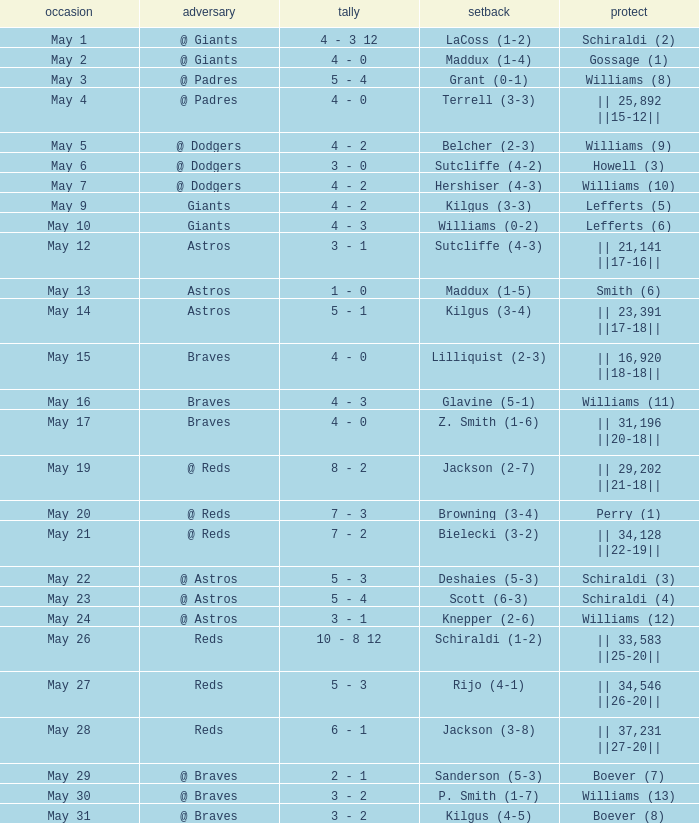Name the loss with save of || 23,391 ||17-18||? Kilgus (3-4). Could you help me parse every detail presented in this table? {'header': ['occasion', 'adversary', 'tally', 'setback', 'protect'], 'rows': [['May 1', '@ Giants', '4 - 3 12', 'LaCoss (1-2)', 'Schiraldi (2)'], ['May 2', '@ Giants', '4 - 0', 'Maddux (1-4)', 'Gossage (1)'], ['May 3', '@ Padres', '5 - 4', 'Grant (0-1)', 'Williams (8)'], ['May 4', '@ Padres', '4 - 0', 'Terrell (3-3)', '|| 25,892 ||15-12||'], ['May 5', '@ Dodgers', '4 - 2', 'Belcher (2-3)', 'Williams (9)'], ['May 6', '@ Dodgers', '3 - 0', 'Sutcliffe (4-2)', 'Howell (3)'], ['May 7', '@ Dodgers', '4 - 2', 'Hershiser (4-3)', 'Williams (10)'], ['May 9', 'Giants', '4 - 2', 'Kilgus (3-3)', 'Lefferts (5)'], ['May 10', 'Giants', '4 - 3', 'Williams (0-2)', 'Lefferts (6)'], ['May 12', 'Astros', '3 - 1', 'Sutcliffe (4-3)', '|| 21,141 ||17-16||'], ['May 13', 'Astros', '1 - 0', 'Maddux (1-5)', 'Smith (6)'], ['May 14', 'Astros', '5 - 1', 'Kilgus (3-4)', '|| 23,391 ||17-18||'], ['May 15', 'Braves', '4 - 0', 'Lilliquist (2-3)', '|| 16,920 ||18-18||'], ['May 16', 'Braves', '4 - 3', 'Glavine (5-1)', 'Williams (11)'], ['May 17', 'Braves', '4 - 0', 'Z. Smith (1-6)', '|| 31,196 ||20-18||'], ['May 19', '@ Reds', '8 - 2', 'Jackson (2-7)', '|| 29,202 ||21-18||'], ['May 20', '@ Reds', '7 - 3', 'Browning (3-4)', 'Perry (1)'], ['May 21', '@ Reds', '7 - 2', 'Bielecki (3-2)', '|| 34,128 ||22-19||'], ['May 22', '@ Astros', '5 - 3', 'Deshaies (5-3)', 'Schiraldi (3)'], ['May 23', '@ Astros', '5 - 4', 'Scott (6-3)', 'Schiraldi (4)'], ['May 24', '@ Astros', '3 - 1', 'Knepper (2-6)', 'Williams (12)'], ['May 26', 'Reds', '10 - 8 12', 'Schiraldi (1-2)', '|| 33,583 ||25-20||'], ['May 27', 'Reds', '5 - 3', 'Rijo (4-1)', '|| 34,546 ||26-20||'], ['May 28', 'Reds', '6 - 1', 'Jackson (3-8)', '|| 37,231 ||27-20||'], ['May 29', '@ Braves', '2 - 1', 'Sanderson (5-3)', 'Boever (7)'], ['May 30', '@ Braves', '3 - 2', 'P. Smith (1-7)', 'Williams (13)'], ['May 31', '@ Braves', '3 - 2', 'Kilgus (4-5)', 'Boever (8)']]} 